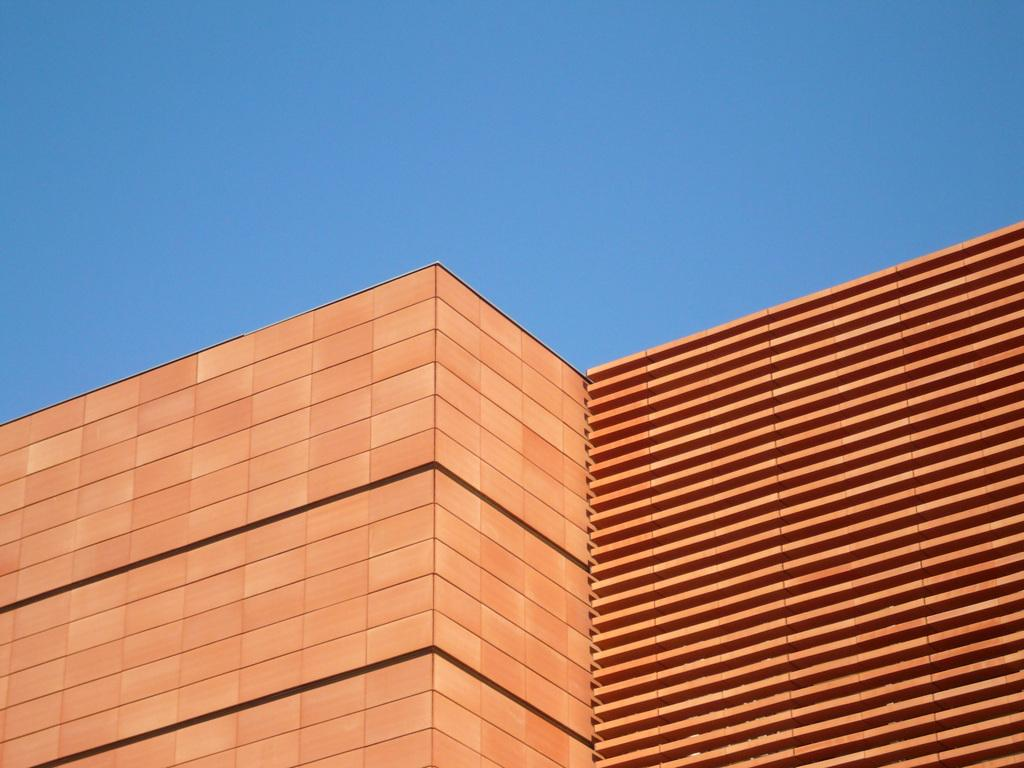What type of structure is present in the image? There is a building in the image. Can you describe the color of the building? The building is orange and black in color. How many men are visible in the image? There are no men present in the image; it only features a building. What is the limit of the oil consumption in the image? There is no mention of oil or its consumption in the image, as it only features a building. 